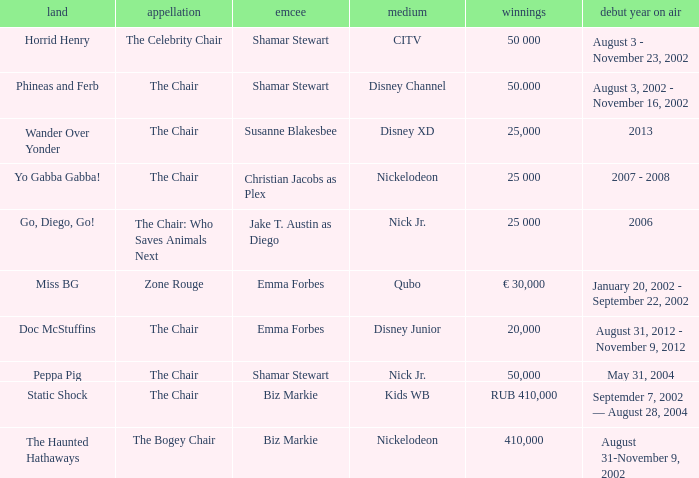What year did Zone Rouge first air? January 20, 2002 - September 22, 2002. 